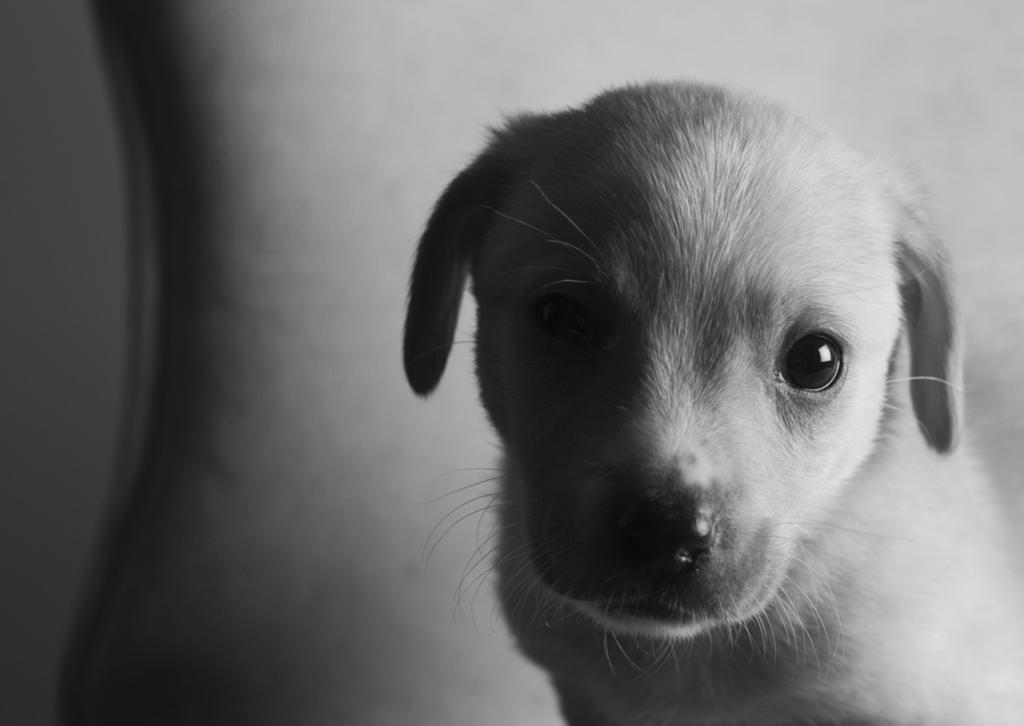Please provide a concise description of this image. In the picture we can see face of a dog. 